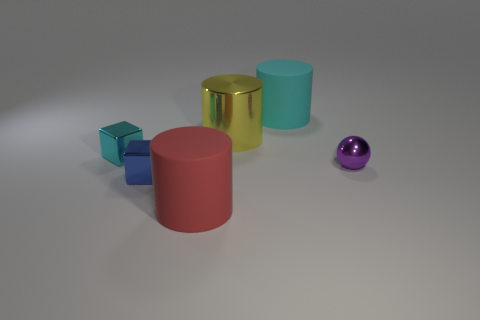Add 2 large purple metal things. How many objects exist? 8 Subtract all big red cylinders. How many cylinders are left? 2 Subtract all spheres. How many objects are left? 5 Subtract all blue cylinders. How many green spheres are left? 0 Subtract all small objects. Subtract all red rubber blocks. How many objects are left? 3 Add 6 small purple metal spheres. How many small purple metal spheres are left? 7 Add 3 small purple objects. How many small purple objects exist? 4 Subtract all cyan blocks. How many blocks are left? 1 Subtract 0 purple cylinders. How many objects are left? 6 Subtract 1 spheres. How many spheres are left? 0 